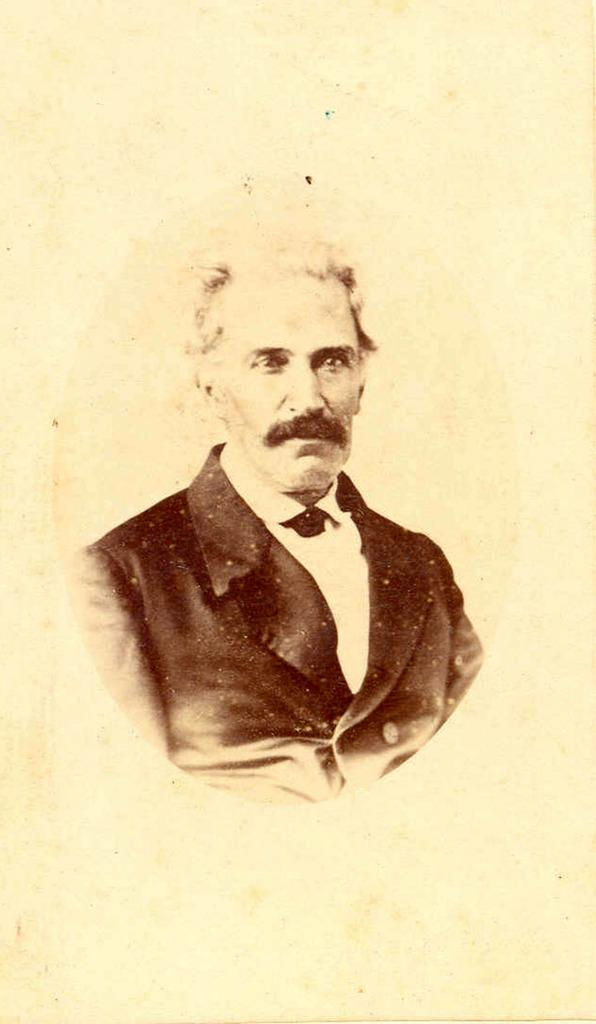What is the main subject of the image? There is a painting in the image. What does the painting depict? The painting depicts a human being. What is the human being wearing in the painting? The human being is wearing a black color suit. Where is the crate located in the image? There is no crate present in the image. What type of station is depicted in the painting? The painting does not depict a station; it depicts a human being wearing a black color suit. 